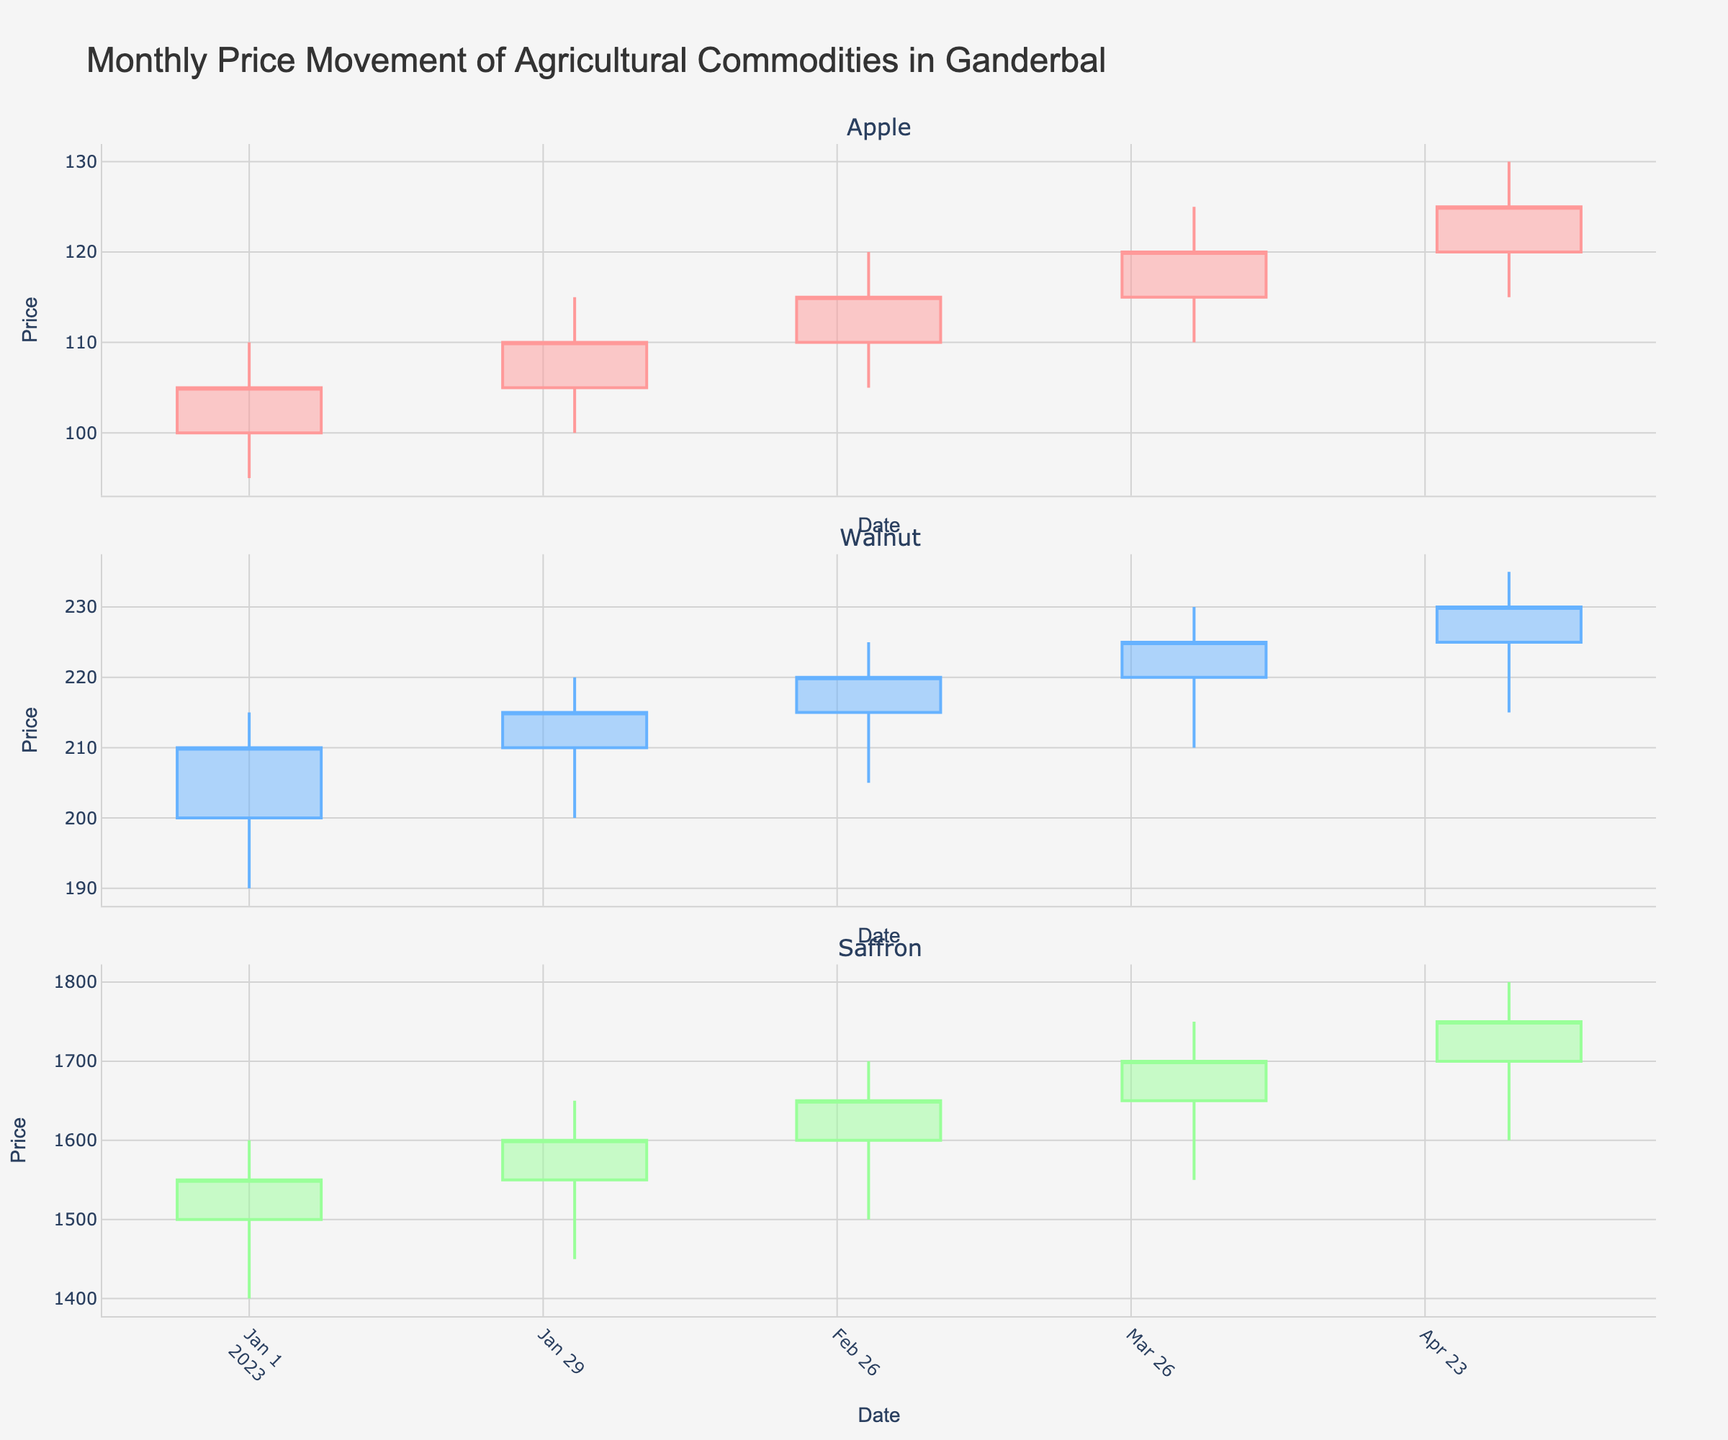What is the main title of the figure? The main title is typically displayed at the top of the figure which describes what the overall plot is about.
Answer: Monthly Price Movement of Agricultural Commodities in Ganderbal What commodities are represented in the figure? The commodities are indicated in the subplot titles or the labels associated with each candlestick plot.
Answer: Apple, Walnut, Saffron Which commodity had the highest closing price in January 2023? For each commodity shown in the figure, locate the candlestick for January 2023 and compare the closing prices.
Answer: Saffron Between Apple and Walnut, which commodity showed a larger increase in its closing price from January to February 2023? Identify the closing prices for Apple and Walnut in both January and February 2023 from the candlesticks, then compute and compare the changes.
Answer: Apple During which month did Saffron's closing price increase by the largest amount compared to the previous month? Examine the closing prices for Saffron across all months and find the month-to-month increases, then identify the largest increase.
Answer: April 2023 Which month had the highest high price for Walnut? Look at the candlesticks for Walnut and find the candlestick with the highest top wick (which represents the high price) among all months.
Answer: May 2023 On average, how does the closing price of Apple change each month? Calculate the change in closing prices of Apple for each month and then compute the average of these changes.
Answer: +5 per month Was there any month where any commodity had a decreasing closing price compared to the previous month? If yes, which commodity and month? Compare the closing prices each month with the previous month for all commodities and check if there are any decreases.
Answer: No, all commodities showed increasing or constant closing prices monthly Which commodity had the smallest price range (difference between high and low) in March 2023? Look at the price ranges (high - low) for all commodities in March 2023 and identify the smallest range.
Answer: Walnut If you invested in Saffron at the beginning of January 2023 and sold at the end of May 2023, what would be your gain in price per unit? Identify the opening price of Saffron in January 2023 and the closing price in May 2023. Calculate the difference between these two prices.
Answer: 250 